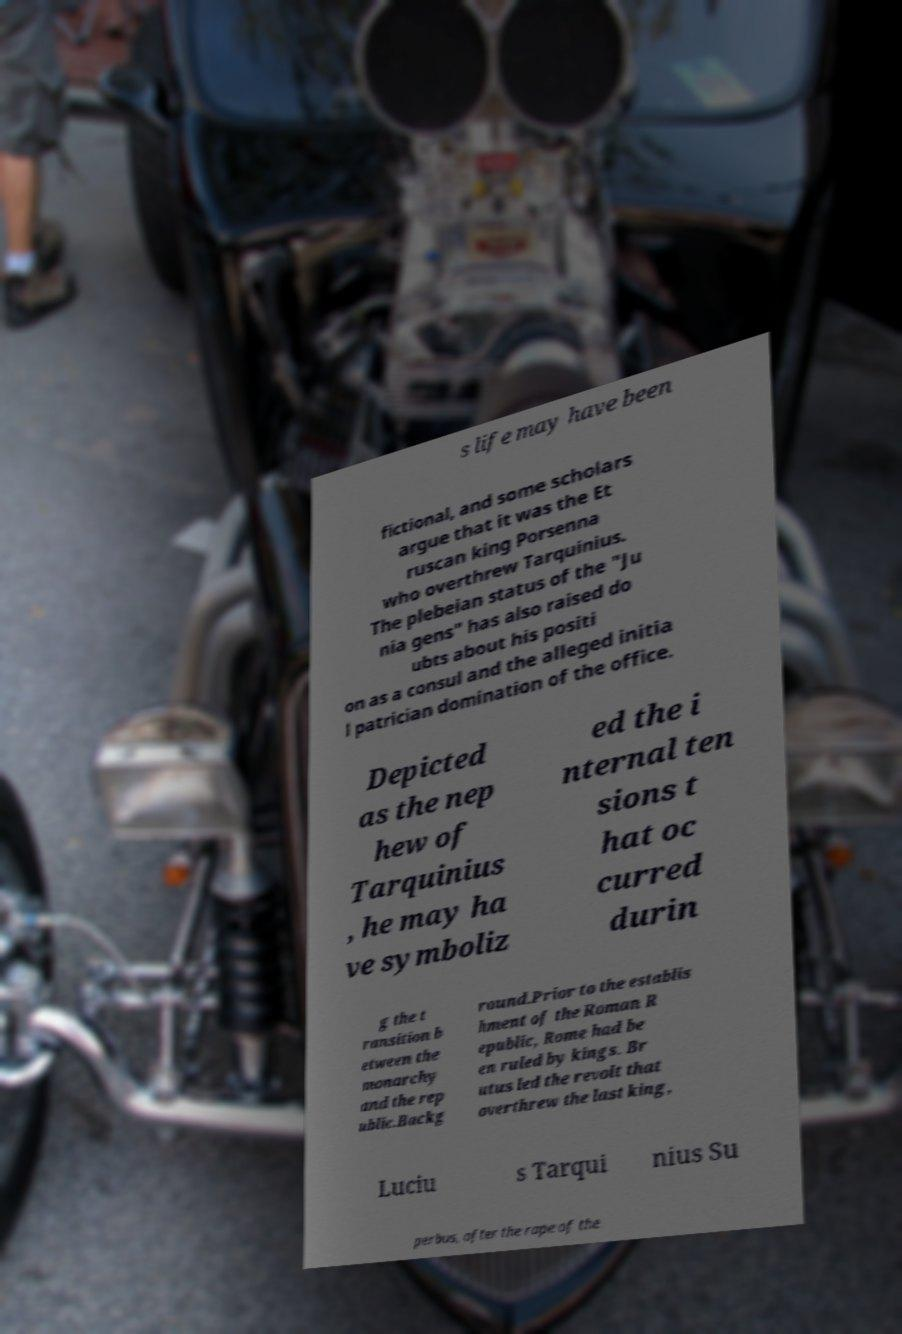Please identify and transcribe the text found in this image. s life may have been fictional, and some scholars argue that it was the Et ruscan king Porsenna who overthrew Tarquinius. The plebeian status of the "Ju nia gens" has also raised do ubts about his positi on as a consul and the alleged initia l patrician domination of the office. Depicted as the nep hew of Tarquinius , he may ha ve symboliz ed the i nternal ten sions t hat oc curred durin g the t ransition b etween the monarchy and the rep ublic.Backg round.Prior to the establis hment of the Roman R epublic, Rome had be en ruled by kings. Br utus led the revolt that overthrew the last king, Luciu s Tarqui nius Su perbus, after the rape of the 